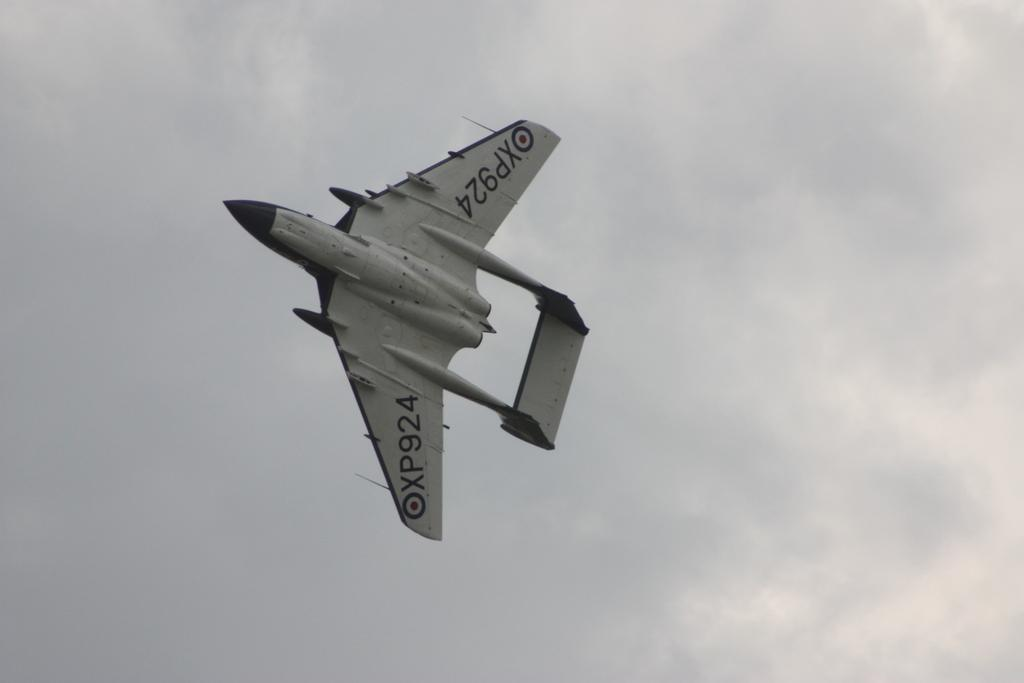<image>
Provide a brief description of the given image. A fighter jet flying in an overcast sky with the tail number XP924. 